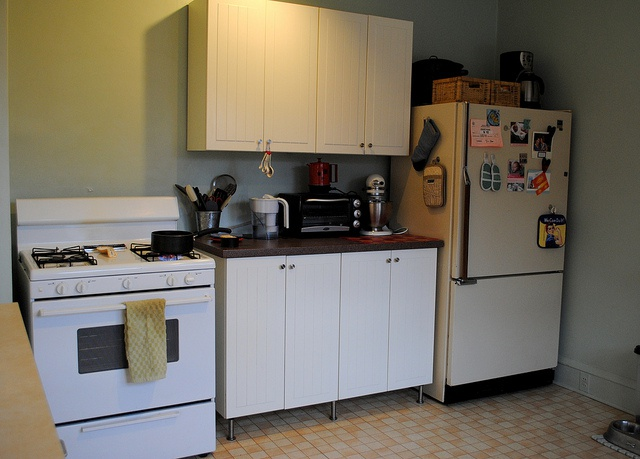Describe the objects in this image and their specific colors. I can see oven in olive, darkgray, black, and gray tones, refrigerator in olive, gray, black, and maroon tones, oven in olive, black, gray, and darkgray tones, bowl in olive, black, gray, and maroon tones, and knife in olive, black, and gray tones in this image. 